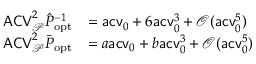Convert formula to latex. <formula><loc_0><loc_0><loc_500><loc_500>\begin{array} { r l } { A C V _ { \mathcal { P } } ^ { 2 } \hat { P } _ { o p t } ^ { - 1 } } & { = a c v _ { 0 } + 6 a c v _ { 0 } ^ { 3 } + \mathcal { O } ( a c v _ { 0 } ^ { 5 } ) } \\ { A C V _ { \mathcal { P } } ^ { 2 } \bar { P } _ { o p t } } & { = a a c v _ { 0 } + b a c v _ { 0 } ^ { 3 } + \mathcal { O } ( a c v _ { 0 } ^ { 5 } ) } \end{array}</formula> 